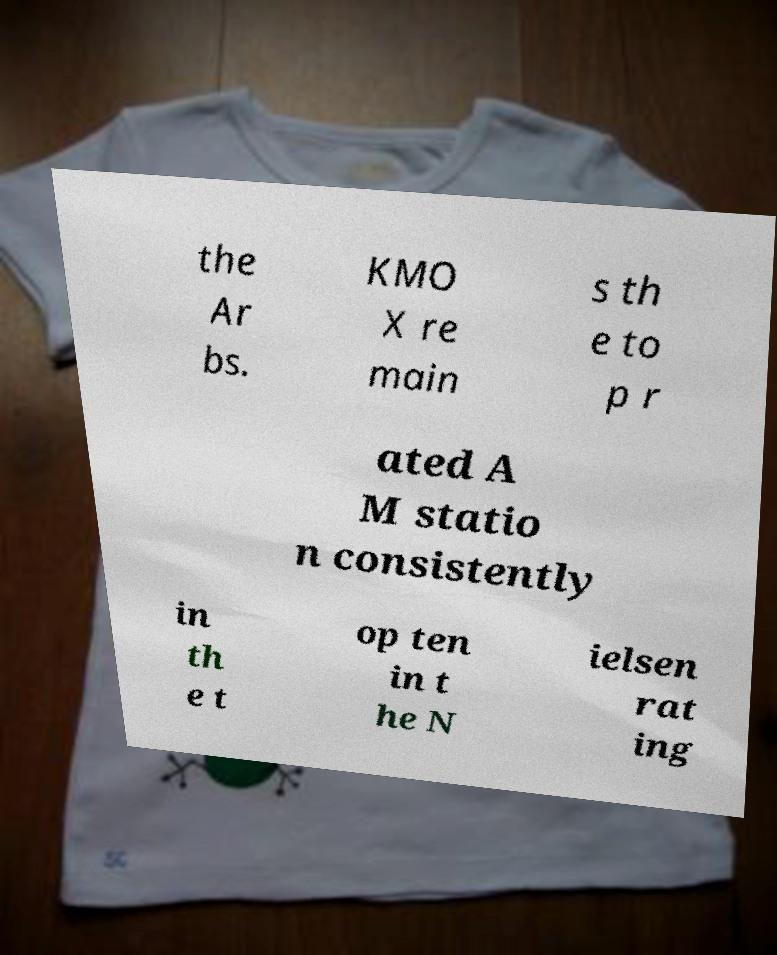Can you accurately transcribe the text from the provided image for me? the Ar bs. KMO X re main s th e to p r ated A M statio n consistently in th e t op ten in t he N ielsen rat ing 